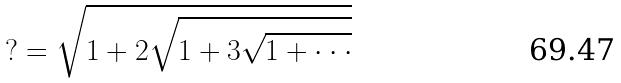<formula> <loc_0><loc_0><loc_500><loc_500>? = \sqrt { 1 + 2 \sqrt { 1 + 3 \sqrt { 1 + \cdot \cdot \cdot } } }</formula> 